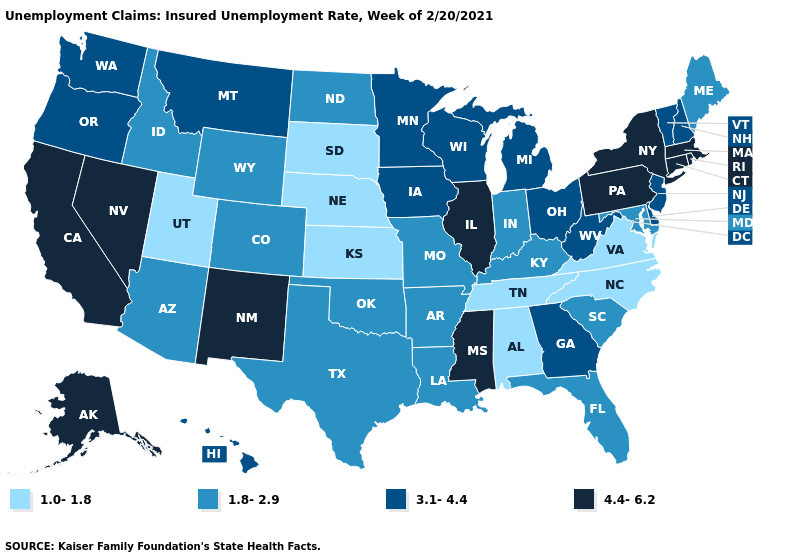What is the highest value in the USA?
Write a very short answer. 4.4-6.2. Among the states that border Michigan , does Ohio have the lowest value?
Be succinct. No. Name the states that have a value in the range 1.0-1.8?
Answer briefly. Alabama, Kansas, Nebraska, North Carolina, South Dakota, Tennessee, Utah, Virginia. Does Illinois have the highest value in the MidWest?
Answer briefly. Yes. Name the states that have a value in the range 1.8-2.9?
Write a very short answer. Arizona, Arkansas, Colorado, Florida, Idaho, Indiana, Kentucky, Louisiana, Maine, Maryland, Missouri, North Dakota, Oklahoma, South Carolina, Texas, Wyoming. What is the value of Pennsylvania?
Answer briefly. 4.4-6.2. What is the value of New Mexico?
Keep it brief. 4.4-6.2. Does New Jersey have the highest value in the USA?
Write a very short answer. No. Name the states that have a value in the range 4.4-6.2?
Short answer required. Alaska, California, Connecticut, Illinois, Massachusetts, Mississippi, Nevada, New Mexico, New York, Pennsylvania, Rhode Island. Does the first symbol in the legend represent the smallest category?
Keep it brief. Yes. Name the states that have a value in the range 1.0-1.8?
Give a very brief answer. Alabama, Kansas, Nebraska, North Carolina, South Dakota, Tennessee, Utah, Virginia. Does New York have the highest value in the USA?
Concise answer only. Yes. Is the legend a continuous bar?
Write a very short answer. No. Does Maine have the lowest value in the Northeast?
Give a very brief answer. Yes. What is the value of Arkansas?
Concise answer only. 1.8-2.9. 